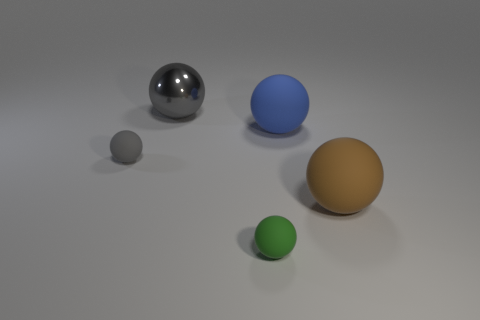Subtract all blue cylinders. How many gray balls are left? 2 Subtract all large blue spheres. How many spheres are left? 4 Subtract all green spheres. How many spheres are left? 4 Add 4 tiny matte balls. How many objects exist? 9 Subtract all yellow spheres. Subtract all gray cylinders. How many spheres are left? 5 Add 3 brown spheres. How many brown spheres are left? 4 Add 1 gray matte things. How many gray matte things exist? 2 Subtract 0 green blocks. How many objects are left? 5 Subtract all tiny purple shiny objects. Subtract all brown things. How many objects are left? 4 